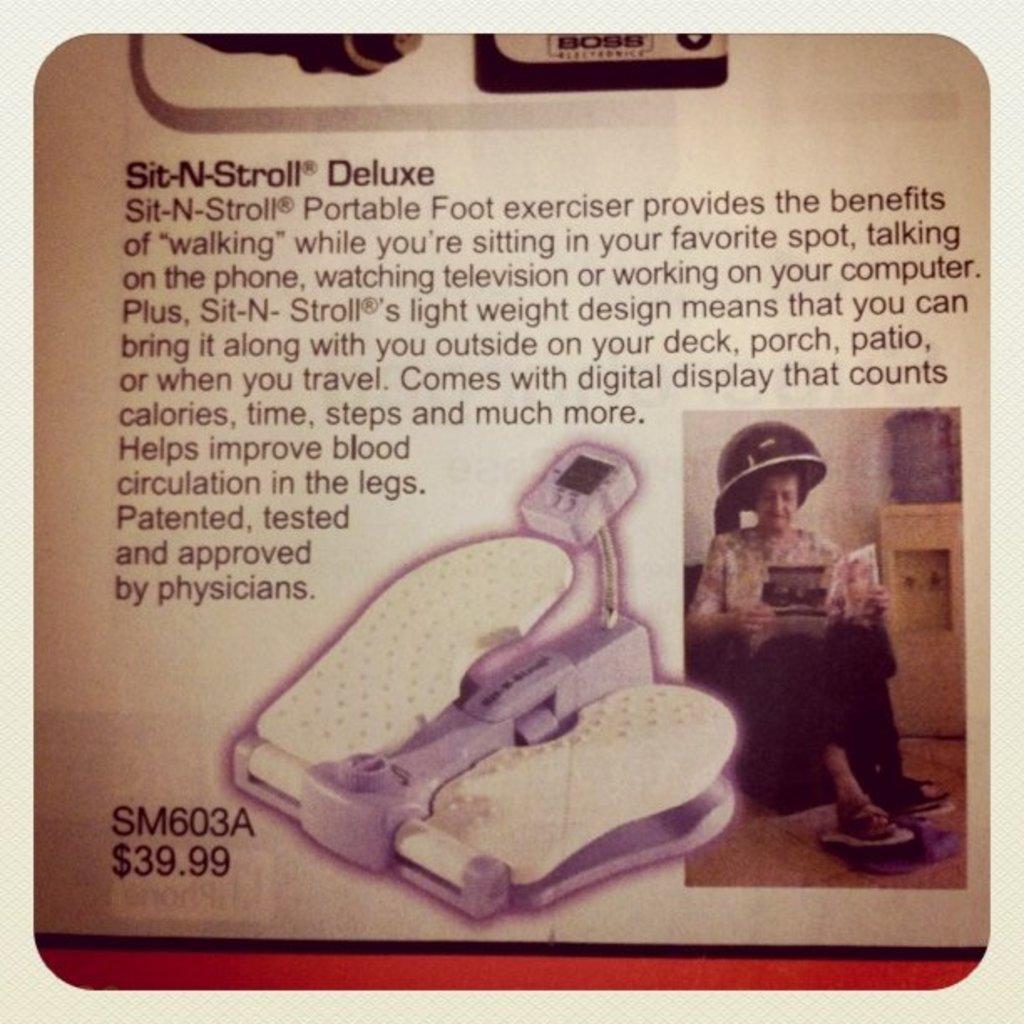In one or two sentences, can you explain what this image depicts? In this image we can see a picture of a newspaper article with some text and image on it. 